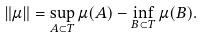Convert formula to latex. <formula><loc_0><loc_0><loc_500><loc_500>\left \| \mu \right \| = \sup _ { A \subset T } \mu ( A ) - \inf _ { B \subset T } \mu ( B ) .</formula> 